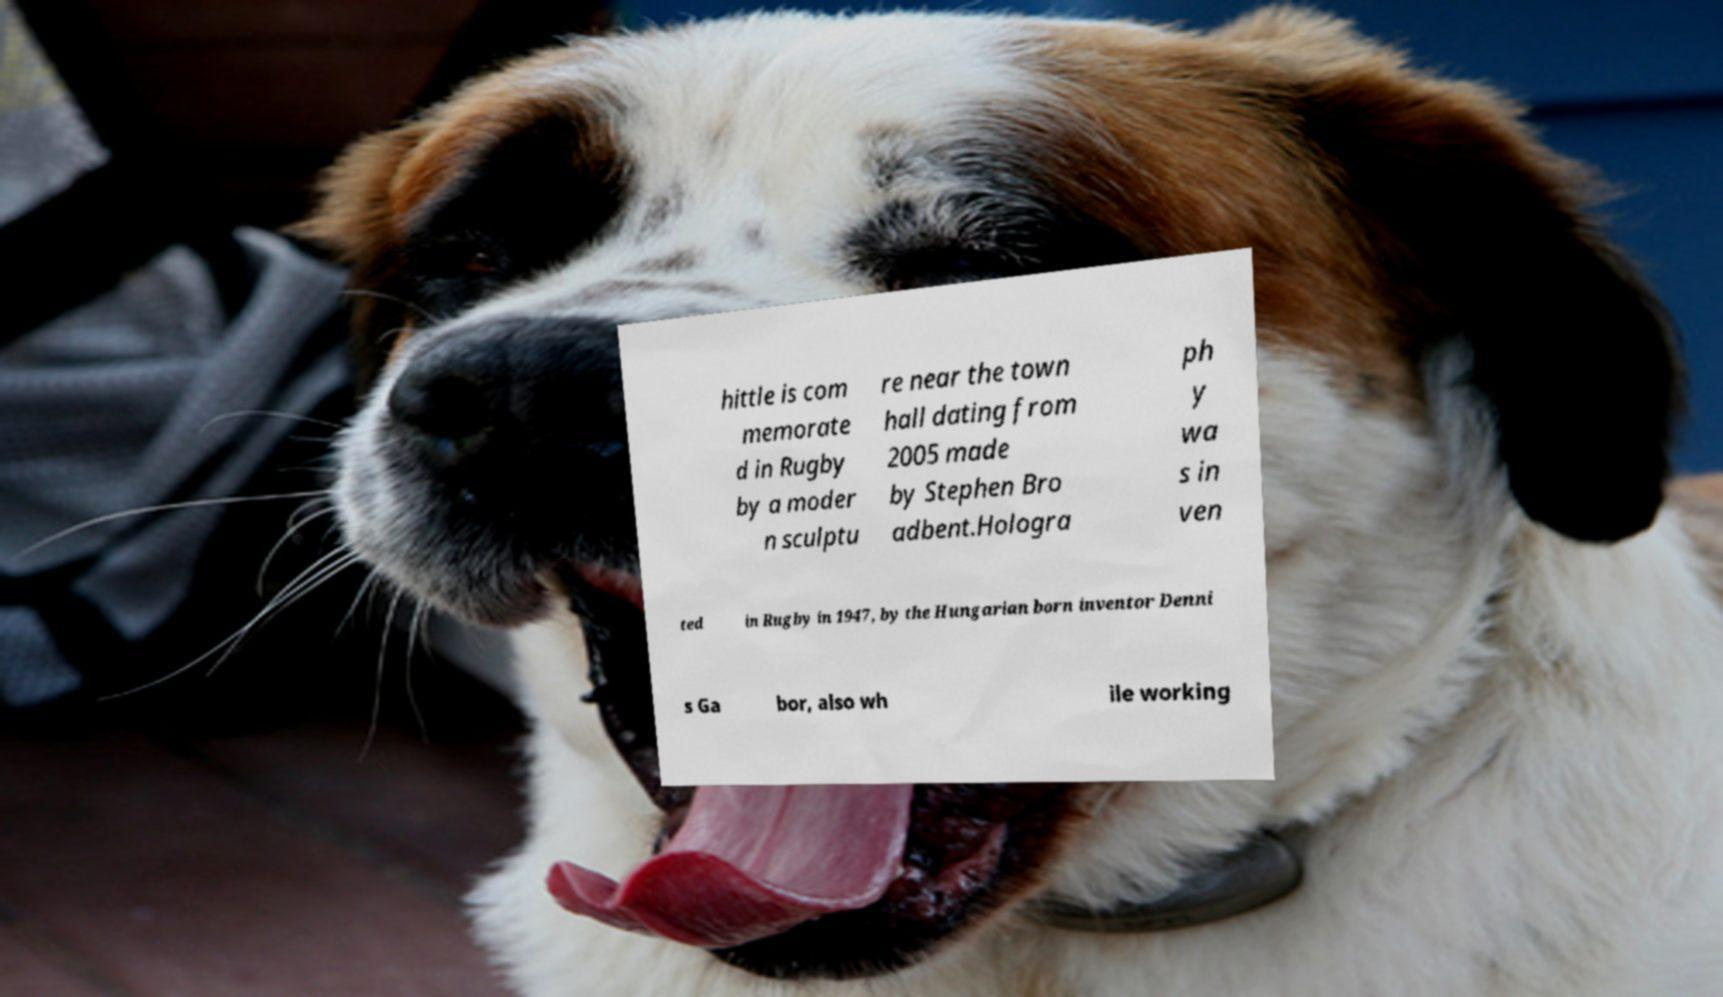Please read and relay the text visible in this image. What does it say? hittle is com memorate d in Rugby by a moder n sculptu re near the town hall dating from 2005 made by Stephen Bro adbent.Hologra ph y wa s in ven ted in Rugby in 1947, by the Hungarian born inventor Denni s Ga bor, also wh ile working 